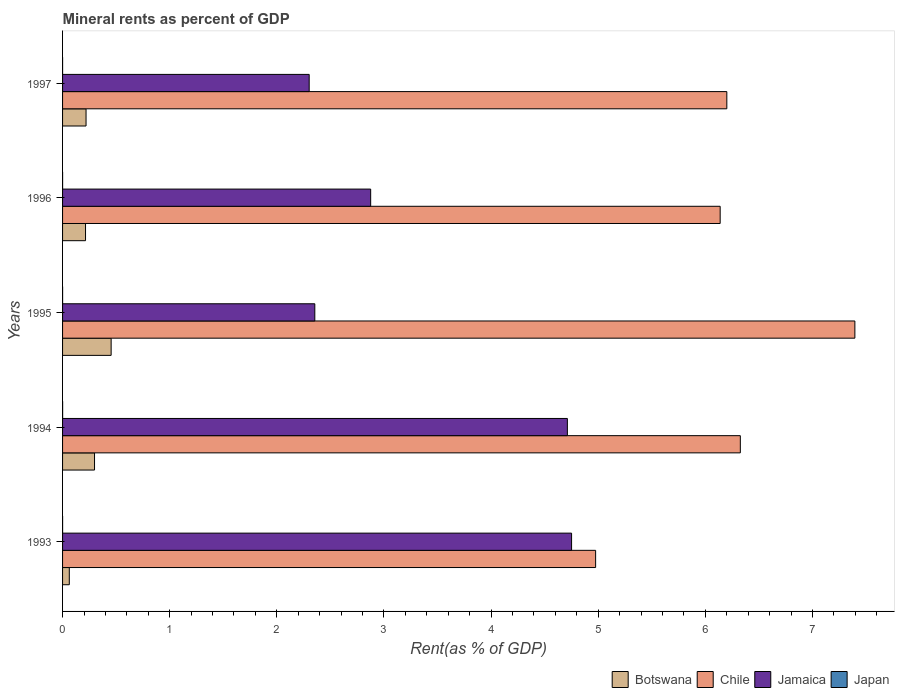How many different coloured bars are there?
Your answer should be very brief. 4. How many groups of bars are there?
Offer a terse response. 5. Are the number of bars per tick equal to the number of legend labels?
Your response must be concise. Yes. How many bars are there on the 4th tick from the bottom?
Make the answer very short. 4. In how many cases, is the number of bars for a given year not equal to the number of legend labels?
Make the answer very short. 0. What is the mineral rent in Japan in 1994?
Give a very brief answer. 0. Across all years, what is the maximum mineral rent in Chile?
Make the answer very short. 7.4. Across all years, what is the minimum mineral rent in Jamaica?
Provide a succinct answer. 2.3. In which year was the mineral rent in Japan minimum?
Offer a terse response. 1997. What is the total mineral rent in Jamaica in the graph?
Provide a succinct answer. 17. What is the difference between the mineral rent in Botswana in 1995 and that in 1997?
Offer a terse response. 0.23. What is the difference between the mineral rent in Japan in 1994 and the mineral rent in Botswana in 1995?
Offer a very short reply. -0.45. What is the average mineral rent in Japan per year?
Offer a very short reply. 0. In the year 1996, what is the difference between the mineral rent in Botswana and mineral rent in Jamaica?
Ensure brevity in your answer.  -2.66. What is the ratio of the mineral rent in Jamaica in 1996 to that in 1997?
Provide a short and direct response. 1.25. Is the difference between the mineral rent in Botswana in 1995 and 1997 greater than the difference between the mineral rent in Jamaica in 1995 and 1997?
Ensure brevity in your answer.  Yes. What is the difference between the highest and the second highest mineral rent in Japan?
Keep it short and to the point. 0. What is the difference between the highest and the lowest mineral rent in Jamaica?
Offer a terse response. 2.45. In how many years, is the mineral rent in Jamaica greater than the average mineral rent in Jamaica taken over all years?
Give a very brief answer. 2. What does the 4th bar from the top in 1995 represents?
Ensure brevity in your answer.  Botswana. What does the 4th bar from the bottom in 1997 represents?
Make the answer very short. Japan. Are the values on the major ticks of X-axis written in scientific E-notation?
Your response must be concise. No. Does the graph contain grids?
Give a very brief answer. No. What is the title of the graph?
Offer a very short reply. Mineral rents as percent of GDP. What is the label or title of the X-axis?
Your response must be concise. Rent(as % of GDP). What is the label or title of the Y-axis?
Provide a succinct answer. Years. What is the Rent(as % of GDP) of Botswana in 1993?
Give a very brief answer. 0.06. What is the Rent(as % of GDP) in Chile in 1993?
Make the answer very short. 4.98. What is the Rent(as % of GDP) in Jamaica in 1993?
Give a very brief answer. 4.75. What is the Rent(as % of GDP) of Japan in 1993?
Give a very brief answer. 0. What is the Rent(as % of GDP) of Botswana in 1994?
Provide a succinct answer. 0.3. What is the Rent(as % of GDP) in Chile in 1994?
Provide a short and direct response. 6.33. What is the Rent(as % of GDP) in Jamaica in 1994?
Offer a terse response. 4.71. What is the Rent(as % of GDP) in Japan in 1994?
Make the answer very short. 0. What is the Rent(as % of GDP) in Botswana in 1995?
Give a very brief answer. 0.45. What is the Rent(as % of GDP) in Chile in 1995?
Ensure brevity in your answer.  7.4. What is the Rent(as % of GDP) in Jamaica in 1995?
Offer a terse response. 2.35. What is the Rent(as % of GDP) in Japan in 1995?
Provide a succinct answer. 0. What is the Rent(as % of GDP) in Botswana in 1996?
Offer a terse response. 0.21. What is the Rent(as % of GDP) in Chile in 1996?
Provide a succinct answer. 6.14. What is the Rent(as % of GDP) of Jamaica in 1996?
Provide a short and direct response. 2.88. What is the Rent(as % of GDP) of Japan in 1996?
Your answer should be very brief. 0. What is the Rent(as % of GDP) in Botswana in 1997?
Your response must be concise. 0.22. What is the Rent(as % of GDP) in Chile in 1997?
Provide a succinct answer. 6.2. What is the Rent(as % of GDP) of Jamaica in 1997?
Your response must be concise. 2.3. What is the Rent(as % of GDP) in Japan in 1997?
Keep it short and to the point. 4.86493891704915e-5. Across all years, what is the maximum Rent(as % of GDP) of Botswana?
Offer a very short reply. 0.45. Across all years, what is the maximum Rent(as % of GDP) in Chile?
Provide a succinct answer. 7.4. Across all years, what is the maximum Rent(as % of GDP) in Jamaica?
Make the answer very short. 4.75. Across all years, what is the maximum Rent(as % of GDP) in Japan?
Offer a very short reply. 0. Across all years, what is the minimum Rent(as % of GDP) in Botswana?
Your response must be concise. 0.06. Across all years, what is the minimum Rent(as % of GDP) in Chile?
Your response must be concise. 4.98. Across all years, what is the minimum Rent(as % of GDP) in Jamaica?
Ensure brevity in your answer.  2.3. Across all years, what is the minimum Rent(as % of GDP) of Japan?
Offer a terse response. 4.86493891704915e-5. What is the total Rent(as % of GDP) in Botswana in the graph?
Ensure brevity in your answer.  1.25. What is the total Rent(as % of GDP) in Chile in the graph?
Provide a short and direct response. 31.04. What is the total Rent(as % of GDP) of Jamaica in the graph?
Provide a succinct answer. 17. What is the total Rent(as % of GDP) in Japan in the graph?
Provide a short and direct response. 0. What is the difference between the Rent(as % of GDP) in Botswana in 1993 and that in 1994?
Ensure brevity in your answer.  -0.24. What is the difference between the Rent(as % of GDP) in Chile in 1993 and that in 1994?
Give a very brief answer. -1.35. What is the difference between the Rent(as % of GDP) of Jamaica in 1993 and that in 1994?
Provide a succinct answer. 0.04. What is the difference between the Rent(as % of GDP) of Japan in 1993 and that in 1994?
Provide a succinct answer. -0. What is the difference between the Rent(as % of GDP) in Botswana in 1993 and that in 1995?
Provide a short and direct response. -0.39. What is the difference between the Rent(as % of GDP) of Chile in 1993 and that in 1995?
Offer a terse response. -2.42. What is the difference between the Rent(as % of GDP) in Jamaica in 1993 and that in 1995?
Make the answer very short. 2.4. What is the difference between the Rent(as % of GDP) in Botswana in 1993 and that in 1996?
Make the answer very short. -0.15. What is the difference between the Rent(as % of GDP) in Chile in 1993 and that in 1996?
Offer a very short reply. -1.16. What is the difference between the Rent(as % of GDP) of Jamaica in 1993 and that in 1996?
Offer a terse response. 1.88. What is the difference between the Rent(as % of GDP) in Japan in 1993 and that in 1996?
Provide a succinct answer. 0. What is the difference between the Rent(as % of GDP) in Botswana in 1993 and that in 1997?
Offer a very short reply. -0.16. What is the difference between the Rent(as % of GDP) of Chile in 1993 and that in 1997?
Offer a terse response. -1.22. What is the difference between the Rent(as % of GDP) of Jamaica in 1993 and that in 1997?
Ensure brevity in your answer.  2.45. What is the difference between the Rent(as % of GDP) of Botswana in 1994 and that in 1995?
Your response must be concise. -0.16. What is the difference between the Rent(as % of GDP) of Chile in 1994 and that in 1995?
Provide a short and direct response. -1.07. What is the difference between the Rent(as % of GDP) of Jamaica in 1994 and that in 1995?
Your answer should be very brief. 2.36. What is the difference between the Rent(as % of GDP) of Botswana in 1994 and that in 1996?
Make the answer very short. 0.08. What is the difference between the Rent(as % of GDP) in Chile in 1994 and that in 1996?
Offer a very short reply. 0.19. What is the difference between the Rent(as % of GDP) of Jamaica in 1994 and that in 1996?
Your response must be concise. 1.84. What is the difference between the Rent(as % of GDP) of Japan in 1994 and that in 1996?
Offer a terse response. 0. What is the difference between the Rent(as % of GDP) of Botswana in 1994 and that in 1997?
Your response must be concise. 0.08. What is the difference between the Rent(as % of GDP) of Chile in 1994 and that in 1997?
Your answer should be compact. 0.13. What is the difference between the Rent(as % of GDP) of Jamaica in 1994 and that in 1997?
Provide a short and direct response. 2.41. What is the difference between the Rent(as % of GDP) in Japan in 1994 and that in 1997?
Offer a very short reply. 0. What is the difference between the Rent(as % of GDP) of Botswana in 1995 and that in 1996?
Your answer should be very brief. 0.24. What is the difference between the Rent(as % of GDP) in Chile in 1995 and that in 1996?
Your answer should be compact. 1.26. What is the difference between the Rent(as % of GDP) of Jamaica in 1995 and that in 1996?
Provide a short and direct response. -0.52. What is the difference between the Rent(as % of GDP) of Japan in 1995 and that in 1996?
Provide a short and direct response. -0. What is the difference between the Rent(as % of GDP) in Botswana in 1995 and that in 1997?
Keep it short and to the point. 0.23. What is the difference between the Rent(as % of GDP) of Chile in 1995 and that in 1997?
Give a very brief answer. 1.2. What is the difference between the Rent(as % of GDP) of Jamaica in 1995 and that in 1997?
Provide a short and direct response. 0.05. What is the difference between the Rent(as % of GDP) in Japan in 1995 and that in 1997?
Provide a short and direct response. 0. What is the difference between the Rent(as % of GDP) of Botswana in 1996 and that in 1997?
Your answer should be compact. -0. What is the difference between the Rent(as % of GDP) in Chile in 1996 and that in 1997?
Offer a very short reply. -0.06. What is the difference between the Rent(as % of GDP) in Jamaica in 1996 and that in 1997?
Your answer should be very brief. 0.57. What is the difference between the Rent(as % of GDP) of Japan in 1996 and that in 1997?
Provide a succinct answer. 0. What is the difference between the Rent(as % of GDP) in Botswana in 1993 and the Rent(as % of GDP) in Chile in 1994?
Offer a terse response. -6.26. What is the difference between the Rent(as % of GDP) in Botswana in 1993 and the Rent(as % of GDP) in Jamaica in 1994?
Provide a short and direct response. -4.65. What is the difference between the Rent(as % of GDP) in Botswana in 1993 and the Rent(as % of GDP) in Japan in 1994?
Offer a very short reply. 0.06. What is the difference between the Rent(as % of GDP) of Chile in 1993 and the Rent(as % of GDP) of Jamaica in 1994?
Your answer should be compact. 0.26. What is the difference between the Rent(as % of GDP) of Chile in 1993 and the Rent(as % of GDP) of Japan in 1994?
Provide a succinct answer. 4.98. What is the difference between the Rent(as % of GDP) of Jamaica in 1993 and the Rent(as % of GDP) of Japan in 1994?
Your response must be concise. 4.75. What is the difference between the Rent(as % of GDP) in Botswana in 1993 and the Rent(as % of GDP) in Chile in 1995?
Your response must be concise. -7.33. What is the difference between the Rent(as % of GDP) of Botswana in 1993 and the Rent(as % of GDP) of Jamaica in 1995?
Make the answer very short. -2.29. What is the difference between the Rent(as % of GDP) of Botswana in 1993 and the Rent(as % of GDP) of Japan in 1995?
Give a very brief answer. 0.06. What is the difference between the Rent(as % of GDP) in Chile in 1993 and the Rent(as % of GDP) in Jamaica in 1995?
Make the answer very short. 2.62. What is the difference between the Rent(as % of GDP) in Chile in 1993 and the Rent(as % of GDP) in Japan in 1995?
Provide a succinct answer. 4.98. What is the difference between the Rent(as % of GDP) in Jamaica in 1993 and the Rent(as % of GDP) in Japan in 1995?
Give a very brief answer. 4.75. What is the difference between the Rent(as % of GDP) in Botswana in 1993 and the Rent(as % of GDP) in Chile in 1996?
Your response must be concise. -6.08. What is the difference between the Rent(as % of GDP) of Botswana in 1993 and the Rent(as % of GDP) of Jamaica in 1996?
Give a very brief answer. -2.81. What is the difference between the Rent(as % of GDP) in Botswana in 1993 and the Rent(as % of GDP) in Japan in 1996?
Provide a succinct answer. 0.06. What is the difference between the Rent(as % of GDP) of Chile in 1993 and the Rent(as % of GDP) of Jamaica in 1996?
Your answer should be very brief. 2.1. What is the difference between the Rent(as % of GDP) of Chile in 1993 and the Rent(as % of GDP) of Japan in 1996?
Offer a very short reply. 4.98. What is the difference between the Rent(as % of GDP) in Jamaica in 1993 and the Rent(as % of GDP) in Japan in 1996?
Ensure brevity in your answer.  4.75. What is the difference between the Rent(as % of GDP) of Botswana in 1993 and the Rent(as % of GDP) of Chile in 1997?
Make the answer very short. -6.14. What is the difference between the Rent(as % of GDP) of Botswana in 1993 and the Rent(as % of GDP) of Jamaica in 1997?
Keep it short and to the point. -2.24. What is the difference between the Rent(as % of GDP) in Botswana in 1993 and the Rent(as % of GDP) in Japan in 1997?
Provide a short and direct response. 0.06. What is the difference between the Rent(as % of GDP) of Chile in 1993 and the Rent(as % of GDP) of Jamaica in 1997?
Give a very brief answer. 2.67. What is the difference between the Rent(as % of GDP) in Chile in 1993 and the Rent(as % of GDP) in Japan in 1997?
Give a very brief answer. 4.98. What is the difference between the Rent(as % of GDP) of Jamaica in 1993 and the Rent(as % of GDP) of Japan in 1997?
Make the answer very short. 4.75. What is the difference between the Rent(as % of GDP) of Botswana in 1994 and the Rent(as % of GDP) of Chile in 1995?
Provide a succinct answer. -7.1. What is the difference between the Rent(as % of GDP) in Botswana in 1994 and the Rent(as % of GDP) in Jamaica in 1995?
Offer a very short reply. -2.06. What is the difference between the Rent(as % of GDP) of Botswana in 1994 and the Rent(as % of GDP) of Japan in 1995?
Offer a very short reply. 0.3. What is the difference between the Rent(as % of GDP) in Chile in 1994 and the Rent(as % of GDP) in Jamaica in 1995?
Give a very brief answer. 3.97. What is the difference between the Rent(as % of GDP) of Chile in 1994 and the Rent(as % of GDP) of Japan in 1995?
Your answer should be compact. 6.33. What is the difference between the Rent(as % of GDP) of Jamaica in 1994 and the Rent(as % of GDP) of Japan in 1995?
Your response must be concise. 4.71. What is the difference between the Rent(as % of GDP) of Botswana in 1994 and the Rent(as % of GDP) of Chile in 1996?
Your answer should be very brief. -5.84. What is the difference between the Rent(as % of GDP) in Botswana in 1994 and the Rent(as % of GDP) in Jamaica in 1996?
Your answer should be compact. -2.58. What is the difference between the Rent(as % of GDP) in Botswana in 1994 and the Rent(as % of GDP) in Japan in 1996?
Make the answer very short. 0.3. What is the difference between the Rent(as % of GDP) in Chile in 1994 and the Rent(as % of GDP) in Jamaica in 1996?
Your answer should be compact. 3.45. What is the difference between the Rent(as % of GDP) in Chile in 1994 and the Rent(as % of GDP) in Japan in 1996?
Make the answer very short. 6.33. What is the difference between the Rent(as % of GDP) of Jamaica in 1994 and the Rent(as % of GDP) of Japan in 1996?
Keep it short and to the point. 4.71. What is the difference between the Rent(as % of GDP) of Botswana in 1994 and the Rent(as % of GDP) of Chile in 1997?
Provide a succinct answer. -5.9. What is the difference between the Rent(as % of GDP) in Botswana in 1994 and the Rent(as % of GDP) in Jamaica in 1997?
Offer a terse response. -2. What is the difference between the Rent(as % of GDP) of Botswana in 1994 and the Rent(as % of GDP) of Japan in 1997?
Give a very brief answer. 0.3. What is the difference between the Rent(as % of GDP) in Chile in 1994 and the Rent(as % of GDP) in Jamaica in 1997?
Keep it short and to the point. 4.02. What is the difference between the Rent(as % of GDP) of Chile in 1994 and the Rent(as % of GDP) of Japan in 1997?
Keep it short and to the point. 6.33. What is the difference between the Rent(as % of GDP) in Jamaica in 1994 and the Rent(as % of GDP) in Japan in 1997?
Give a very brief answer. 4.71. What is the difference between the Rent(as % of GDP) in Botswana in 1995 and the Rent(as % of GDP) in Chile in 1996?
Keep it short and to the point. -5.68. What is the difference between the Rent(as % of GDP) in Botswana in 1995 and the Rent(as % of GDP) in Jamaica in 1996?
Provide a short and direct response. -2.42. What is the difference between the Rent(as % of GDP) in Botswana in 1995 and the Rent(as % of GDP) in Japan in 1996?
Ensure brevity in your answer.  0.45. What is the difference between the Rent(as % of GDP) of Chile in 1995 and the Rent(as % of GDP) of Jamaica in 1996?
Your answer should be very brief. 4.52. What is the difference between the Rent(as % of GDP) of Chile in 1995 and the Rent(as % of GDP) of Japan in 1996?
Offer a terse response. 7.4. What is the difference between the Rent(as % of GDP) of Jamaica in 1995 and the Rent(as % of GDP) of Japan in 1996?
Give a very brief answer. 2.35. What is the difference between the Rent(as % of GDP) in Botswana in 1995 and the Rent(as % of GDP) in Chile in 1997?
Provide a short and direct response. -5.75. What is the difference between the Rent(as % of GDP) of Botswana in 1995 and the Rent(as % of GDP) of Jamaica in 1997?
Offer a terse response. -1.85. What is the difference between the Rent(as % of GDP) in Botswana in 1995 and the Rent(as % of GDP) in Japan in 1997?
Keep it short and to the point. 0.45. What is the difference between the Rent(as % of GDP) in Chile in 1995 and the Rent(as % of GDP) in Jamaica in 1997?
Your answer should be very brief. 5.09. What is the difference between the Rent(as % of GDP) of Chile in 1995 and the Rent(as % of GDP) of Japan in 1997?
Ensure brevity in your answer.  7.4. What is the difference between the Rent(as % of GDP) in Jamaica in 1995 and the Rent(as % of GDP) in Japan in 1997?
Give a very brief answer. 2.35. What is the difference between the Rent(as % of GDP) in Botswana in 1996 and the Rent(as % of GDP) in Chile in 1997?
Ensure brevity in your answer.  -5.99. What is the difference between the Rent(as % of GDP) of Botswana in 1996 and the Rent(as % of GDP) of Jamaica in 1997?
Provide a short and direct response. -2.09. What is the difference between the Rent(as % of GDP) of Botswana in 1996 and the Rent(as % of GDP) of Japan in 1997?
Give a very brief answer. 0.21. What is the difference between the Rent(as % of GDP) of Chile in 1996 and the Rent(as % of GDP) of Jamaica in 1997?
Make the answer very short. 3.84. What is the difference between the Rent(as % of GDP) in Chile in 1996 and the Rent(as % of GDP) in Japan in 1997?
Make the answer very short. 6.14. What is the difference between the Rent(as % of GDP) in Jamaica in 1996 and the Rent(as % of GDP) in Japan in 1997?
Provide a short and direct response. 2.88. What is the average Rent(as % of GDP) of Botswana per year?
Ensure brevity in your answer.  0.25. What is the average Rent(as % of GDP) of Chile per year?
Your answer should be compact. 6.21. What is the average Rent(as % of GDP) of Jamaica per year?
Offer a very short reply. 3.4. What is the average Rent(as % of GDP) in Japan per year?
Provide a succinct answer. 0. In the year 1993, what is the difference between the Rent(as % of GDP) of Botswana and Rent(as % of GDP) of Chile?
Your response must be concise. -4.91. In the year 1993, what is the difference between the Rent(as % of GDP) in Botswana and Rent(as % of GDP) in Jamaica?
Offer a terse response. -4.69. In the year 1993, what is the difference between the Rent(as % of GDP) of Botswana and Rent(as % of GDP) of Japan?
Your answer should be very brief. 0.06. In the year 1993, what is the difference between the Rent(as % of GDP) of Chile and Rent(as % of GDP) of Jamaica?
Make the answer very short. 0.22. In the year 1993, what is the difference between the Rent(as % of GDP) of Chile and Rent(as % of GDP) of Japan?
Your answer should be compact. 4.98. In the year 1993, what is the difference between the Rent(as % of GDP) in Jamaica and Rent(as % of GDP) in Japan?
Ensure brevity in your answer.  4.75. In the year 1994, what is the difference between the Rent(as % of GDP) in Botswana and Rent(as % of GDP) in Chile?
Give a very brief answer. -6.03. In the year 1994, what is the difference between the Rent(as % of GDP) in Botswana and Rent(as % of GDP) in Jamaica?
Ensure brevity in your answer.  -4.41. In the year 1994, what is the difference between the Rent(as % of GDP) in Botswana and Rent(as % of GDP) in Japan?
Your answer should be very brief. 0.3. In the year 1994, what is the difference between the Rent(as % of GDP) of Chile and Rent(as % of GDP) of Jamaica?
Provide a short and direct response. 1.61. In the year 1994, what is the difference between the Rent(as % of GDP) of Chile and Rent(as % of GDP) of Japan?
Your answer should be compact. 6.33. In the year 1994, what is the difference between the Rent(as % of GDP) in Jamaica and Rent(as % of GDP) in Japan?
Offer a very short reply. 4.71. In the year 1995, what is the difference between the Rent(as % of GDP) of Botswana and Rent(as % of GDP) of Chile?
Give a very brief answer. -6.94. In the year 1995, what is the difference between the Rent(as % of GDP) in Botswana and Rent(as % of GDP) in Jamaica?
Give a very brief answer. -1.9. In the year 1995, what is the difference between the Rent(as % of GDP) of Botswana and Rent(as % of GDP) of Japan?
Keep it short and to the point. 0.45. In the year 1995, what is the difference between the Rent(as % of GDP) of Chile and Rent(as % of GDP) of Jamaica?
Make the answer very short. 5.04. In the year 1995, what is the difference between the Rent(as % of GDP) of Chile and Rent(as % of GDP) of Japan?
Your answer should be very brief. 7.4. In the year 1995, what is the difference between the Rent(as % of GDP) in Jamaica and Rent(as % of GDP) in Japan?
Make the answer very short. 2.35. In the year 1996, what is the difference between the Rent(as % of GDP) in Botswana and Rent(as % of GDP) in Chile?
Keep it short and to the point. -5.92. In the year 1996, what is the difference between the Rent(as % of GDP) of Botswana and Rent(as % of GDP) of Jamaica?
Ensure brevity in your answer.  -2.66. In the year 1996, what is the difference between the Rent(as % of GDP) in Botswana and Rent(as % of GDP) in Japan?
Offer a terse response. 0.21. In the year 1996, what is the difference between the Rent(as % of GDP) in Chile and Rent(as % of GDP) in Jamaica?
Provide a succinct answer. 3.26. In the year 1996, what is the difference between the Rent(as % of GDP) in Chile and Rent(as % of GDP) in Japan?
Your response must be concise. 6.14. In the year 1996, what is the difference between the Rent(as % of GDP) in Jamaica and Rent(as % of GDP) in Japan?
Your response must be concise. 2.88. In the year 1997, what is the difference between the Rent(as % of GDP) of Botswana and Rent(as % of GDP) of Chile?
Provide a succinct answer. -5.98. In the year 1997, what is the difference between the Rent(as % of GDP) of Botswana and Rent(as % of GDP) of Jamaica?
Offer a very short reply. -2.08. In the year 1997, what is the difference between the Rent(as % of GDP) of Botswana and Rent(as % of GDP) of Japan?
Ensure brevity in your answer.  0.22. In the year 1997, what is the difference between the Rent(as % of GDP) of Chile and Rent(as % of GDP) of Jamaica?
Your answer should be compact. 3.9. In the year 1997, what is the difference between the Rent(as % of GDP) in Chile and Rent(as % of GDP) in Japan?
Give a very brief answer. 6.2. In the year 1997, what is the difference between the Rent(as % of GDP) in Jamaica and Rent(as % of GDP) in Japan?
Keep it short and to the point. 2.3. What is the ratio of the Rent(as % of GDP) in Botswana in 1993 to that in 1994?
Keep it short and to the point. 0.21. What is the ratio of the Rent(as % of GDP) of Chile in 1993 to that in 1994?
Offer a terse response. 0.79. What is the ratio of the Rent(as % of GDP) of Jamaica in 1993 to that in 1994?
Make the answer very short. 1.01. What is the ratio of the Rent(as % of GDP) in Japan in 1993 to that in 1994?
Ensure brevity in your answer.  0.62. What is the ratio of the Rent(as % of GDP) in Botswana in 1993 to that in 1995?
Offer a terse response. 0.14. What is the ratio of the Rent(as % of GDP) in Chile in 1993 to that in 1995?
Offer a very short reply. 0.67. What is the ratio of the Rent(as % of GDP) of Jamaica in 1993 to that in 1995?
Your response must be concise. 2.02. What is the ratio of the Rent(as % of GDP) in Japan in 1993 to that in 1995?
Offer a very short reply. 1.3. What is the ratio of the Rent(as % of GDP) of Botswana in 1993 to that in 1996?
Your answer should be very brief. 0.29. What is the ratio of the Rent(as % of GDP) in Chile in 1993 to that in 1996?
Your answer should be compact. 0.81. What is the ratio of the Rent(as % of GDP) in Jamaica in 1993 to that in 1996?
Keep it short and to the point. 1.65. What is the ratio of the Rent(as % of GDP) of Japan in 1993 to that in 1996?
Your answer should be very brief. 1.07. What is the ratio of the Rent(as % of GDP) in Botswana in 1993 to that in 1997?
Your answer should be compact. 0.29. What is the ratio of the Rent(as % of GDP) in Chile in 1993 to that in 1997?
Keep it short and to the point. 0.8. What is the ratio of the Rent(as % of GDP) of Jamaica in 1993 to that in 1997?
Your answer should be compact. 2.06. What is the ratio of the Rent(as % of GDP) in Japan in 1993 to that in 1997?
Keep it short and to the point. 6.81. What is the ratio of the Rent(as % of GDP) in Botswana in 1994 to that in 1995?
Your answer should be very brief. 0.66. What is the ratio of the Rent(as % of GDP) of Chile in 1994 to that in 1995?
Offer a very short reply. 0.86. What is the ratio of the Rent(as % of GDP) of Jamaica in 1994 to that in 1995?
Make the answer very short. 2. What is the ratio of the Rent(as % of GDP) of Japan in 1994 to that in 1995?
Ensure brevity in your answer.  2.08. What is the ratio of the Rent(as % of GDP) in Botswana in 1994 to that in 1996?
Make the answer very short. 1.39. What is the ratio of the Rent(as % of GDP) of Chile in 1994 to that in 1996?
Ensure brevity in your answer.  1.03. What is the ratio of the Rent(as % of GDP) of Jamaica in 1994 to that in 1996?
Ensure brevity in your answer.  1.64. What is the ratio of the Rent(as % of GDP) in Japan in 1994 to that in 1996?
Your answer should be very brief. 1.72. What is the ratio of the Rent(as % of GDP) in Botswana in 1994 to that in 1997?
Make the answer very short. 1.36. What is the ratio of the Rent(as % of GDP) in Chile in 1994 to that in 1997?
Your response must be concise. 1.02. What is the ratio of the Rent(as % of GDP) of Jamaica in 1994 to that in 1997?
Your response must be concise. 2.05. What is the ratio of the Rent(as % of GDP) of Japan in 1994 to that in 1997?
Provide a succinct answer. 10.94. What is the ratio of the Rent(as % of GDP) in Botswana in 1995 to that in 1996?
Your answer should be compact. 2.12. What is the ratio of the Rent(as % of GDP) of Chile in 1995 to that in 1996?
Provide a short and direct response. 1.2. What is the ratio of the Rent(as % of GDP) in Jamaica in 1995 to that in 1996?
Give a very brief answer. 0.82. What is the ratio of the Rent(as % of GDP) in Japan in 1995 to that in 1996?
Your answer should be very brief. 0.83. What is the ratio of the Rent(as % of GDP) in Botswana in 1995 to that in 1997?
Keep it short and to the point. 2.07. What is the ratio of the Rent(as % of GDP) in Chile in 1995 to that in 1997?
Keep it short and to the point. 1.19. What is the ratio of the Rent(as % of GDP) of Jamaica in 1995 to that in 1997?
Offer a very short reply. 1.02. What is the ratio of the Rent(as % of GDP) of Japan in 1995 to that in 1997?
Give a very brief answer. 5.25. What is the ratio of the Rent(as % of GDP) of Botswana in 1996 to that in 1997?
Offer a terse response. 0.98. What is the ratio of the Rent(as % of GDP) in Chile in 1996 to that in 1997?
Your answer should be compact. 0.99. What is the ratio of the Rent(as % of GDP) in Jamaica in 1996 to that in 1997?
Make the answer very short. 1.25. What is the ratio of the Rent(as % of GDP) of Japan in 1996 to that in 1997?
Give a very brief answer. 6.35. What is the difference between the highest and the second highest Rent(as % of GDP) in Botswana?
Offer a terse response. 0.16. What is the difference between the highest and the second highest Rent(as % of GDP) of Chile?
Offer a terse response. 1.07. What is the difference between the highest and the second highest Rent(as % of GDP) in Jamaica?
Provide a succinct answer. 0.04. What is the difference between the highest and the second highest Rent(as % of GDP) of Japan?
Your answer should be compact. 0. What is the difference between the highest and the lowest Rent(as % of GDP) in Botswana?
Your answer should be very brief. 0.39. What is the difference between the highest and the lowest Rent(as % of GDP) in Chile?
Your answer should be very brief. 2.42. What is the difference between the highest and the lowest Rent(as % of GDP) of Jamaica?
Keep it short and to the point. 2.45. What is the difference between the highest and the lowest Rent(as % of GDP) of Japan?
Your answer should be compact. 0. 